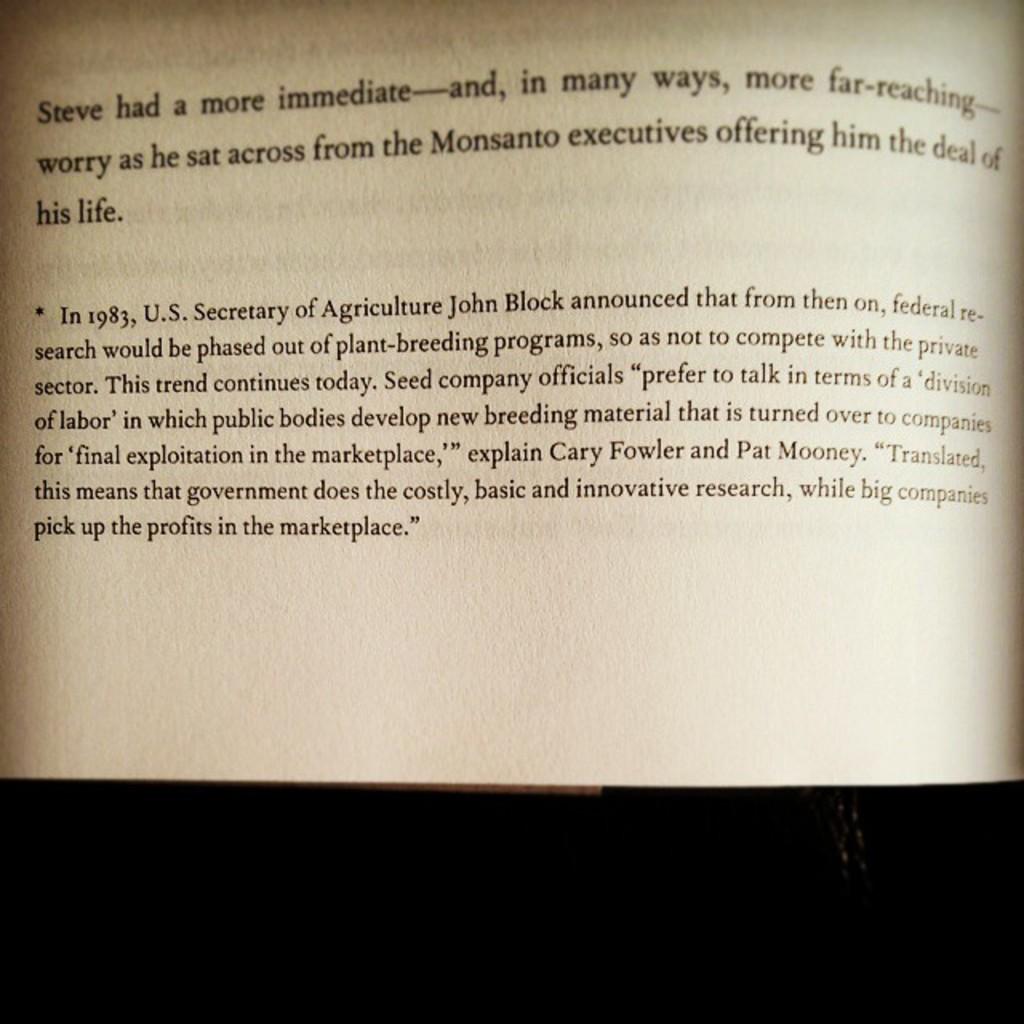What year did john block make an announcement?
Ensure brevity in your answer.  1983. Who did steve sit across from?
Keep it short and to the point. Monsanto executives. 